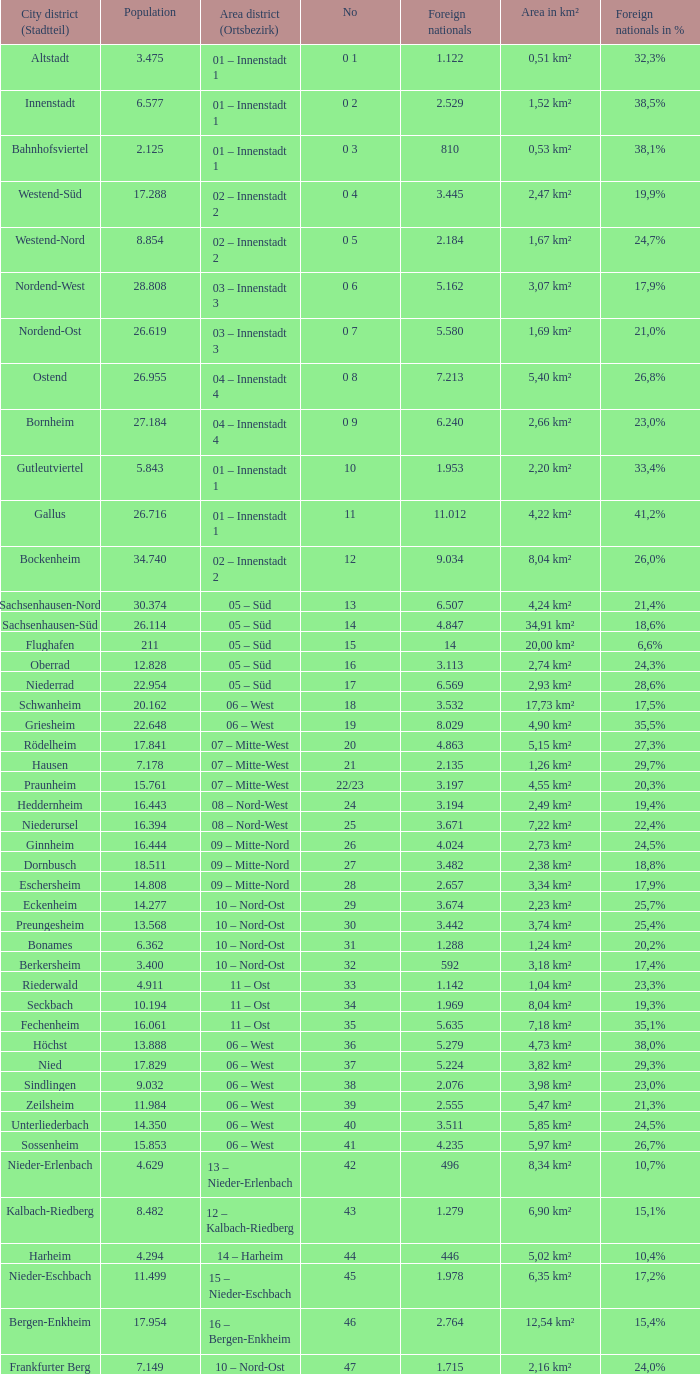What is the city where the number is 47? Frankfurter Berg. 